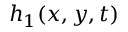<formula> <loc_0><loc_0><loc_500><loc_500>h _ { 1 } ( x , y , t )</formula> 